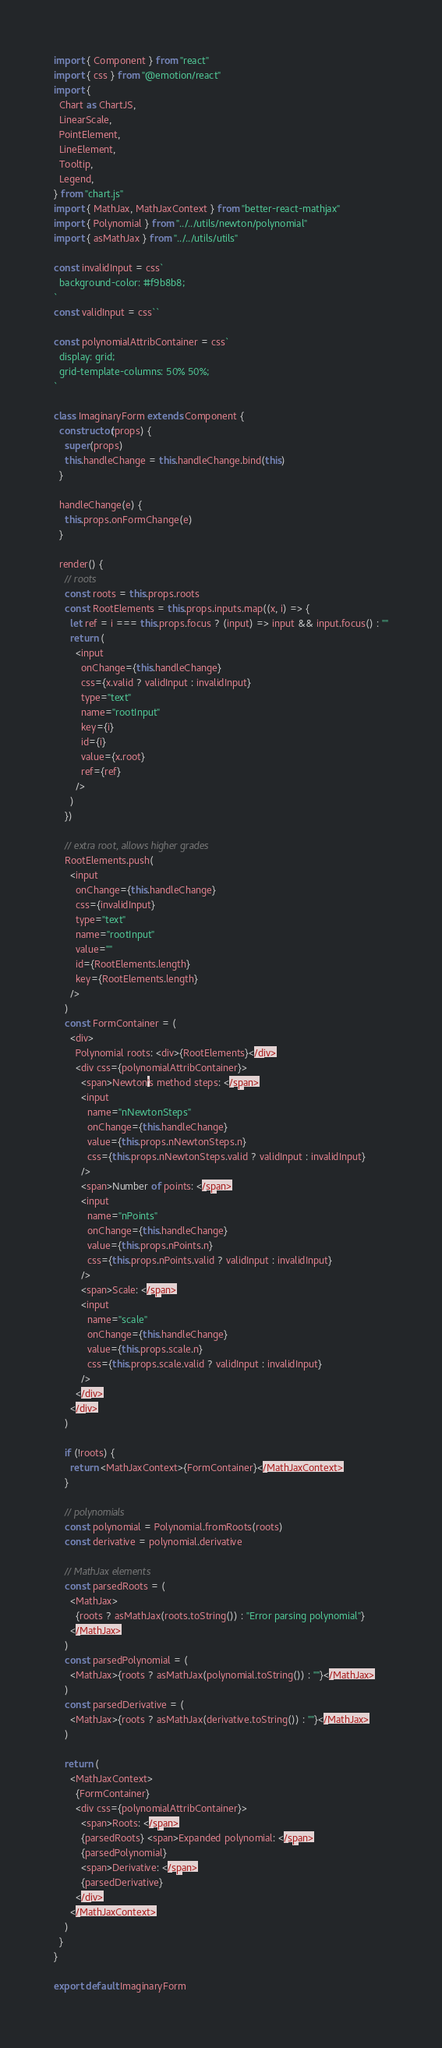Convert code to text. <code><loc_0><loc_0><loc_500><loc_500><_JavaScript_>import { Component } from "react"
import { css } from "@emotion/react"
import {
  Chart as ChartJS,
  LinearScale,
  PointElement,
  LineElement,
  Tooltip,
  Legend,
} from "chart.js"
import { MathJax, MathJaxContext } from "better-react-mathjax"
import { Polynomial } from "../../utils/newton/polynomial"
import { asMathJax } from "../../utils/utils"

const invalidInput = css`
  background-color: #f9b8b8;
`
const validInput = css``

const polynomialAttribContainer = css`
  display: grid;
  grid-template-columns: 50% 50%;
`

class ImaginaryForm extends Component {
  constructor(props) {
    super(props)
    this.handleChange = this.handleChange.bind(this)
  }

  handleChange(e) {
    this.props.onFormChange(e)
  }

  render() {
    // roots
    const roots = this.props.roots
    const RootElements = this.props.inputs.map((x, i) => {
      let ref = i === this.props.focus ? (input) => input && input.focus() : ""
      return (
        <input
          onChange={this.handleChange}
          css={x.valid ? validInput : invalidInput}
          type="text"
          name="rootInput"
          key={i}
          id={i}
          value={x.root}
          ref={ref}
        />
      )
    })

    // extra root, allows higher grades
    RootElements.push(
      <input
        onChange={this.handleChange}
        css={invalidInput}
        type="text"
        name="rootInput"
        value=""
        id={RootElements.length}
        key={RootElements.length}
      />
    )
    const FormContainer = (
      <div>
        Polynomial roots: <div>{RootElements}</div>
        <div css={polynomialAttribContainer}>
          <span>Newton's method steps: </span>
          <input
            name="nNewtonSteps"
            onChange={this.handleChange}
            value={this.props.nNewtonSteps.n}
            css={this.props.nNewtonSteps.valid ? validInput : invalidInput}
          />
          <span>Number of points: </span>
          <input
            name="nPoints"
            onChange={this.handleChange}
            value={this.props.nPoints.n}
            css={this.props.nPoints.valid ? validInput : invalidInput}
          />
          <span>Scale: </span>
          <input
            name="scale"
            onChange={this.handleChange}
            value={this.props.scale.n}
            css={this.props.scale.valid ? validInput : invalidInput}
          />
        </div>
      </div>
    )

    if (!roots) {
      return <MathJaxContext>{FormContainer}</MathJaxContext>
    }

    // polynomials
    const polynomial = Polynomial.fromRoots(roots)
    const derivative = polynomial.derivative

    // MathJax elements
    const parsedRoots = (
      <MathJax>
        {roots ? asMathJax(roots.toString()) : "Error parsing polynomial"}
      </MathJax>
    )
    const parsedPolynomial = (
      <MathJax>{roots ? asMathJax(polynomial.toString()) : ""}</MathJax>
    )
    const parsedDerivative = (
      <MathJax>{roots ? asMathJax(derivative.toString()) : ""}</MathJax>
    )

    return (
      <MathJaxContext>
        {FormContainer}
        <div css={polynomialAttribContainer}>
          <span>Roots: </span>
          {parsedRoots} <span>Expanded polynomial: </span>
          {parsedPolynomial}
          <span>Derivative: </span>
          {parsedDerivative}
        </div>
      </MathJaxContext>
    )
  }
}

export default ImaginaryForm
</code> 